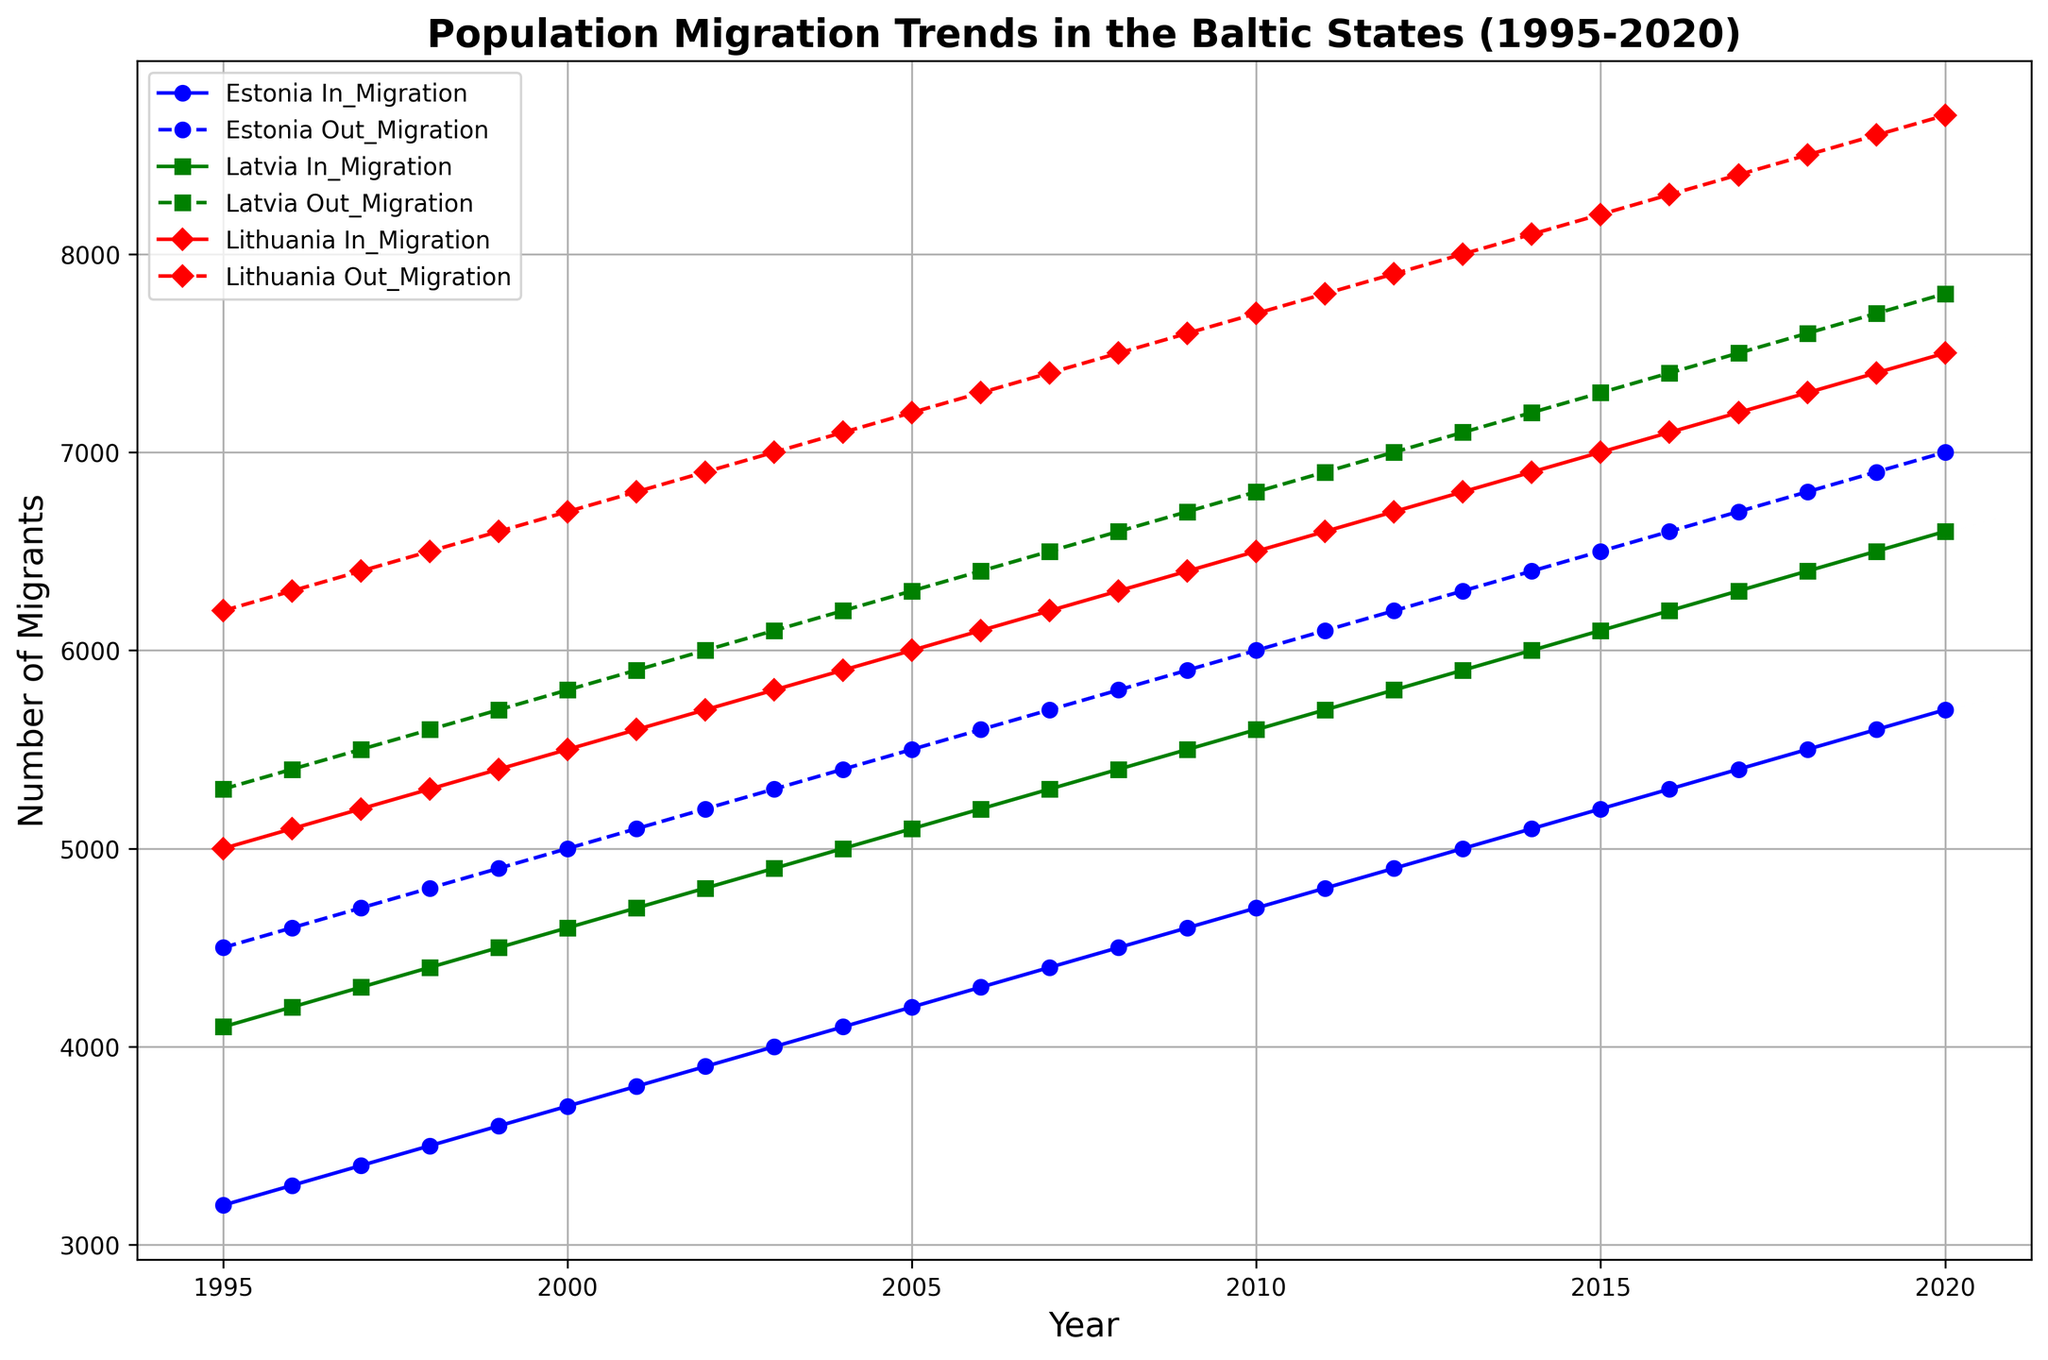What is the general trend of in-migration and out-migration for Estonia from 1995 to 2020? The plot shows both in-migration and out-migration for Estonia. From 1995 to 2020, in-migration and out-migration for Estonia both increased. The in-migration increased from 3200 to 5700, while the out-migration increased from 4500 to 7000.
Answer: Both increased Which country had the highest number of out-migrants in the year 2000? By looking at the dashed lines for 2000, one can see that Lithuania had the highest number of out-migrants, with the out-migration line reaching 6700, compared to Estonia and Latvia that had considerably lower values.
Answer: Lithuania When comparing the years 2000 and 2020, which country experienced the greatest increase in in-migration? Calculating in-migration increase from 2000 to 2020 for each country: Estonia (5700-3700=2000), Latvia (6600-4600=2000), and Lithuania (7500-5500=2000). Hence, they all experienced the same increase of 2000 in-migrants.
Answer: Estonia, Latvia, and Lithuania What is the difference between in-migration and out-migration for Latvia in 2015? The in-migration for Latvia in 2015 is 6100 and the out-migration is 7300. Subtracting in-migration from out-migration gives 7300 - 6100 = 1200.
Answer: 1200 Which country had the smallest gap between in-migration and out-migration in 2005, and what was the value? Analyzing 2005: Estonia (5500-4200=1300), Latvia (6300-5100=1200), Lithuania (7200-6000=1200). Both Latvia and Lithuania had the smallest gap, each with 1200.
Answer: Latvia and Lithuania; 1200 During which year did Estonia's in-migration surpass 5000? The in-migration line for Estonia surpasses 5000 in the year 2012.
Answer: 2012 How did the difference between in-migration and out-migration trend for Lithuania from 1995 to 2020? The difference in Lithuania starts at 1200 (6200-5000) in 1995 and gradually increases until reaching 1200 (8700-7500) again in 2020, indicating a consistently widening gap.
Answer: Increased Which country shows a consistent upward trend in both in-migration and out-migration without any year of decline? Both in-migration and out-migration for each of the three countries (Estonia, Latvia, Lithuania) consistently show an upward trend across the whole period without any decline. Hence all three demonstrate the consistent upward trend.
Answer: Estonia, Latvia, and Lithuania 